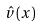<formula> <loc_0><loc_0><loc_500><loc_500>\hat { v } ( x )</formula> 